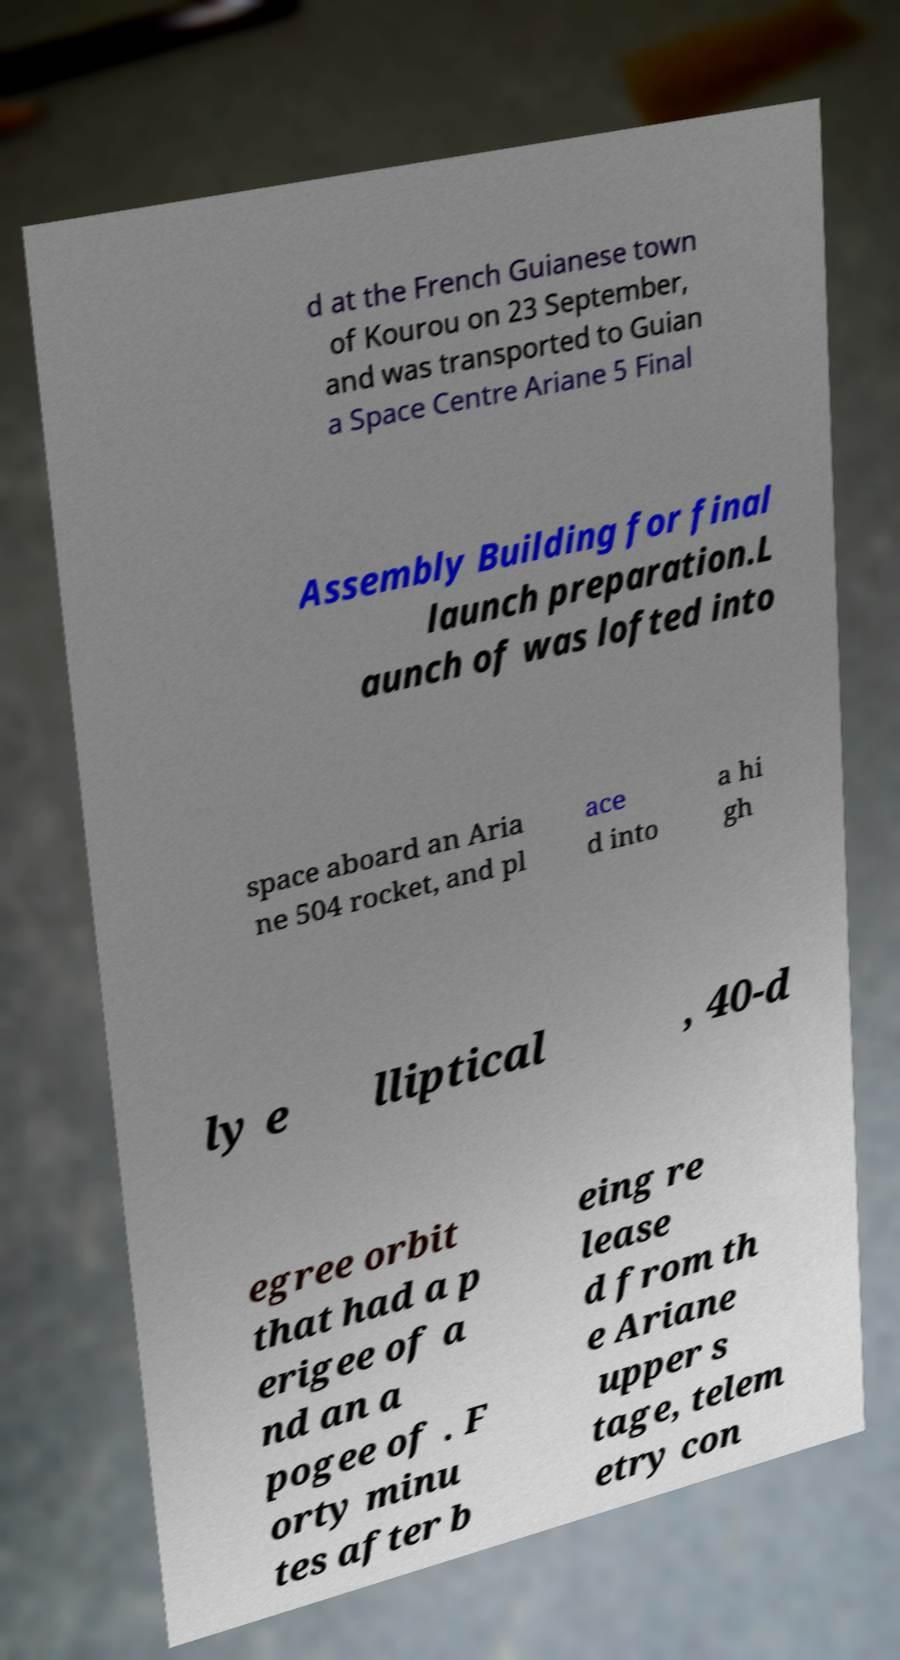What messages or text are displayed in this image? I need them in a readable, typed format. d at the French Guianese town of Kourou on 23 September, and was transported to Guian a Space Centre Ariane 5 Final Assembly Building for final launch preparation.L aunch of was lofted into space aboard an Aria ne 504 rocket, and pl ace d into a hi gh ly e lliptical , 40-d egree orbit that had a p erigee of a nd an a pogee of . F orty minu tes after b eing re lease d from th e Ariane upper s tage, telem etry con 